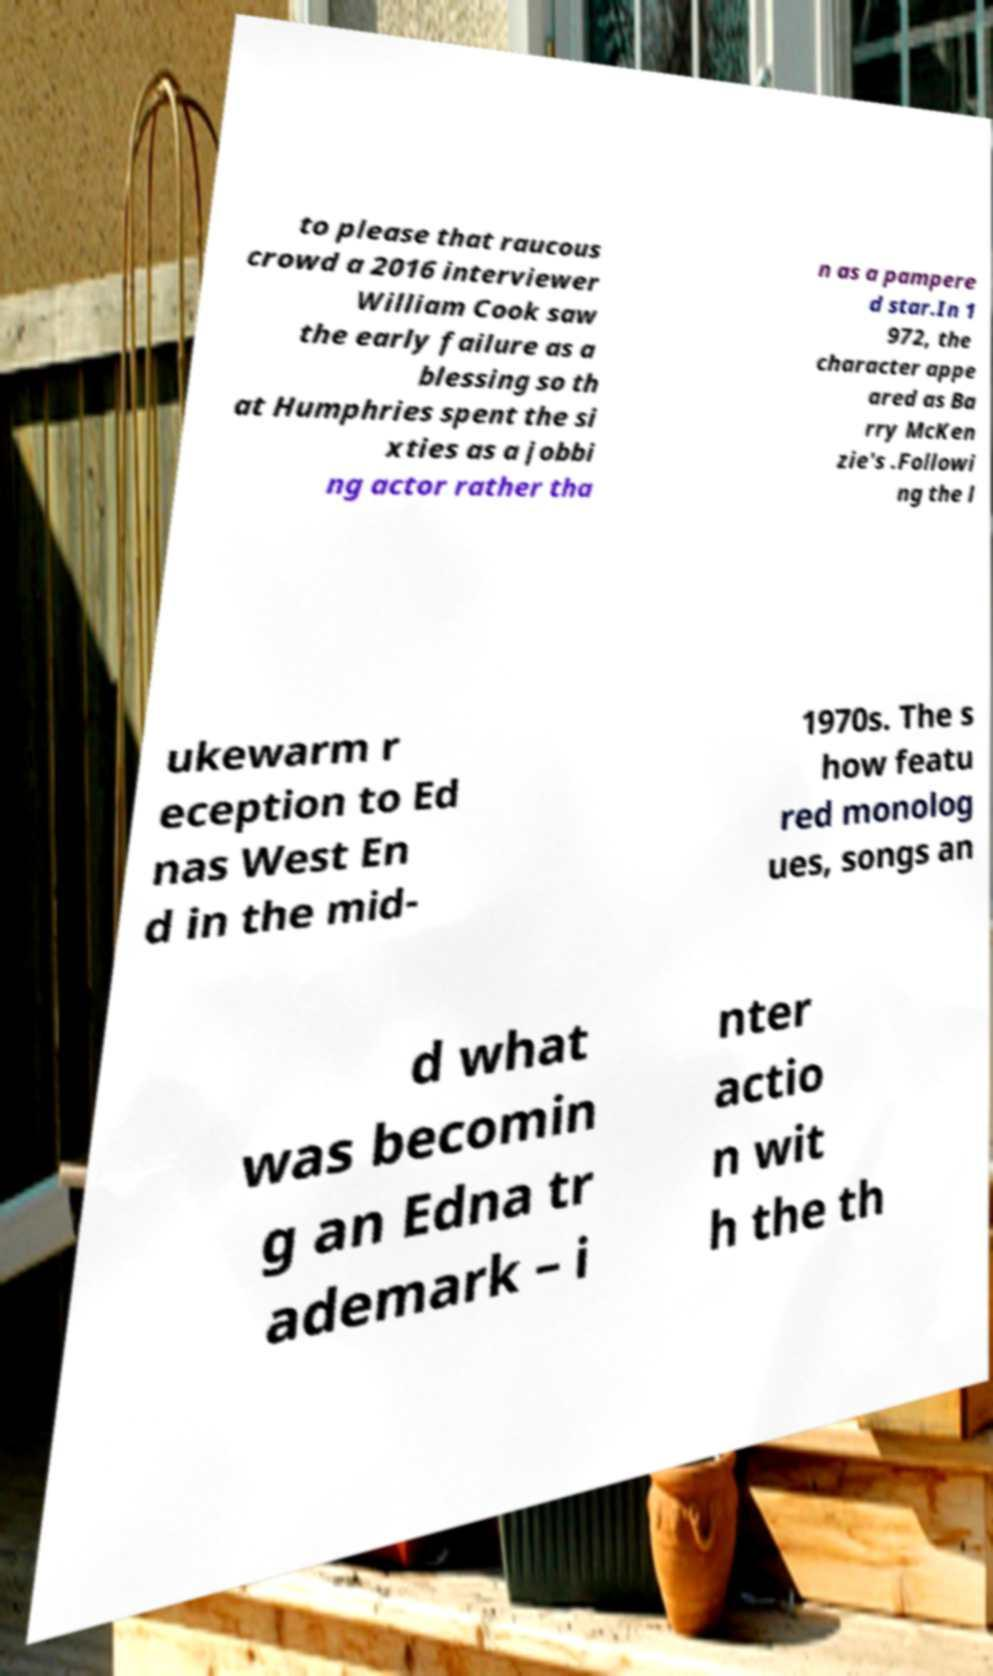There's text embedded in this image that I need extracted. Can you transcribe it verbatim? to please that raucous crowd a 2016 interviewer William Cook saw the early failure as a blessing so th at Humphries spent the si xties as a jobbi ng actor rather tha n as a pampere d star.In 1 972, the character appe ared as Ba rry McKen zie's .Followi ng the l ukewarm r eception to Ed nas West En d in the mid- 1970s. The s how featu red monolog ues, songs an d what was becomin g an Edna tr ademark – i nter actio n wit h the th 